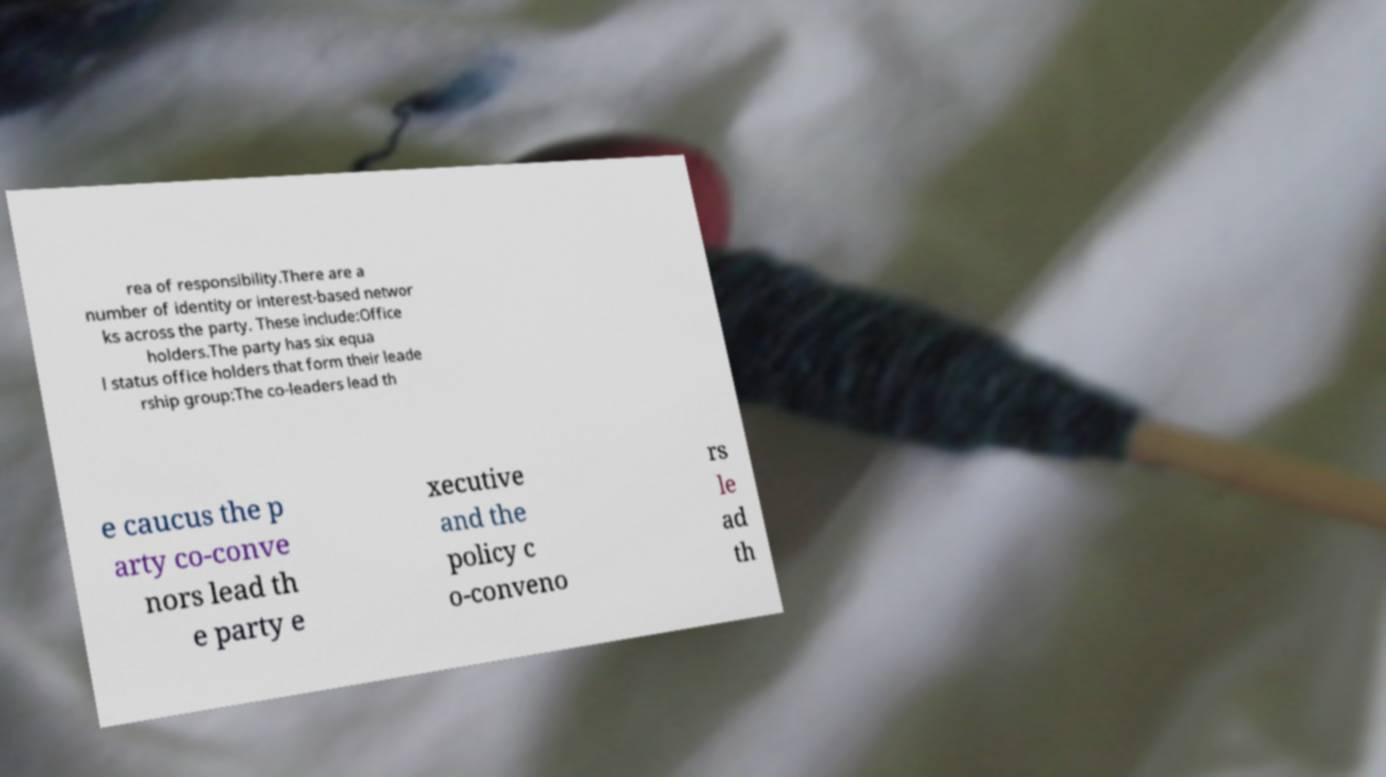Please identify and transcribe the text found in this image. rea of responsibility.There are a number of identity or interest-based networ ks across the party. These include:Office holders.The party has six equa l status office holders that form their leade rship group:The co-leaders lead th e caucus the p arty co-conve nors lead th e party e xecutive and the policy c o-conveno rs le ad th 